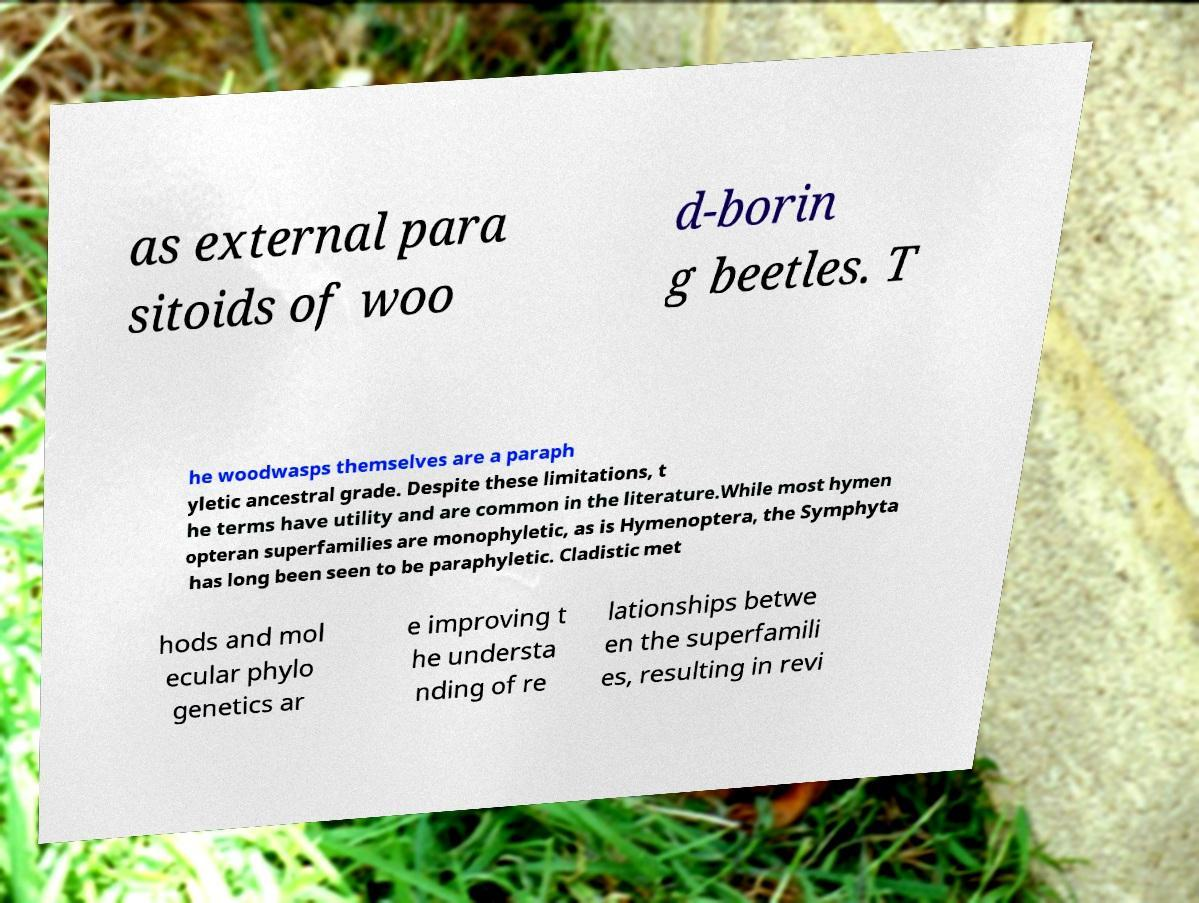For documentation purposes, I need the text within this image transcribed. Could you provide that? as external para sitoids of woo d-borin g beetles. T he woodwasps themselves are a paraph yletic ancestral grade. Despite these limitations, t he terms have utility and are common in the literature.While most hymen opteran superfamilies are monophyletic, as is Hymenoptera, the Symphyta has long been seen to be paraphyletic. Cladistic met hods and mol ecular phylo genetics ar e improving t he understa nding of re lationships betwe en the superfamili es, resulting in revi 